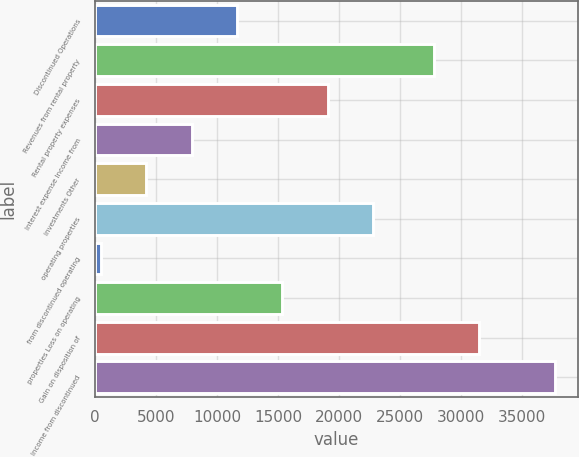<chart> <loc_0><loc_0><loc_500><loc_500><bar_chart><fcel>Discontinued Operations<fcel>Revenues from rental property<fcel>Rental property expenses<fcel>Interest expense Income from<fcel>investments Other<fcel>operating properties<fcel>from discontinued operating<fcel>properties Loss on operating<fcel>Gain on disposition of<fcel>Income from discontinued<nl><fcel>11637.5<fcel>27757<fcel>19078.5<fcel>7917<fcel>4196.5<fcel>22799<fcel>476<fcel>15358<fcel>31477.5<fcel>37681<nl></chart> 